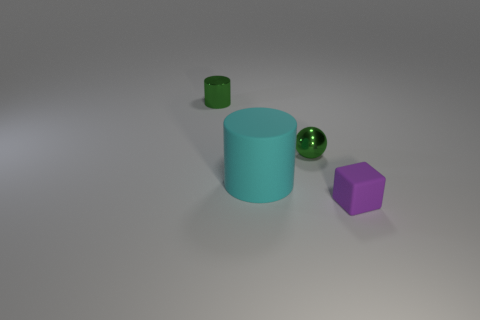Subtract all green cylinders. How many cylinders are left? 1 Add 1 tiny shiny cylinders. How many objects exist? 5 Add 4 large cyan cylinders. How many large cyan cylinders exist? 5 Subtract 0 brown cubes. How many objects are left? 4 Subtract all spheres. How many objects are left? 3 Subtract 1 blocks. How many blocks are left? 0 Subtract all cyan cylinders. Subtract all brown spheres. How many cylinders are left? 1 Subtract all purple balls. How many red cylinders are left? 0 Subtract all green balls. Subtract all tiny green shiny cylinders. How many objects are left? 2 Add 4 small green things. How many small green things are left? 6 